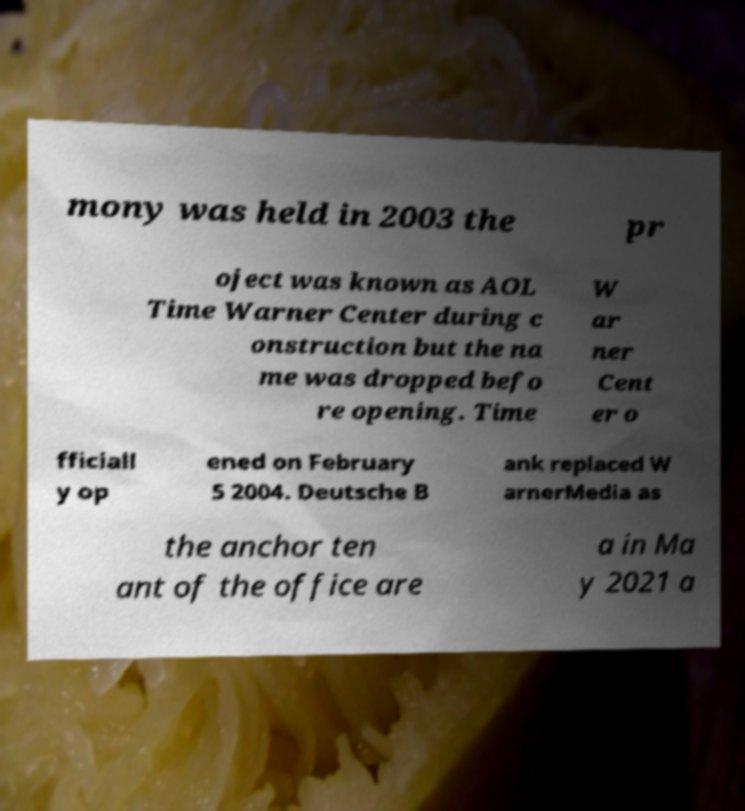Could you extract and type out the text from this image? mony was held in 2003 the pr oject was known as AOL Time Warner Center during c onstruction but the na me was dropped befo re opening. Time W ar ner Cent er o fficiall y op ened on February 5 2004. Deutsche B ank replaced W arnerMedia as the anchor ten ant of the office are a in Ma y 2021 a 